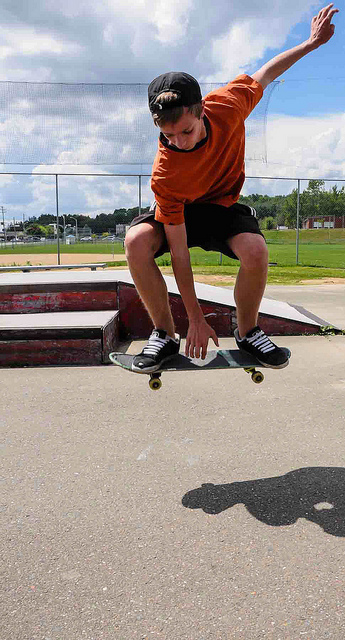What time of day does this photo seem to capture? The photo seems to be taken during the daytime, inferred from the clear sky and the bright sunlight casting a sharp shadow of the skateboarder onto the ground. How does the shadow add to this photo? The shadow adds a dramatic effect, emphasizing the motion and height of the skater's jump. It also provides a sense of the time of day and direction of the sunlight, adding depth to the photograph. 